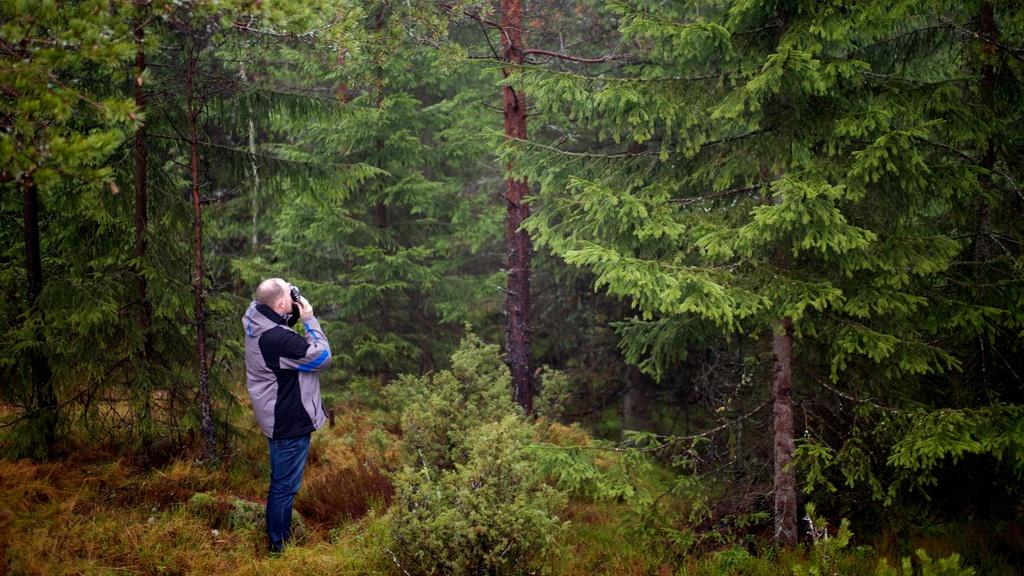What type of vegetation is at the bottom of the image? There is grass at the bottom of the image. What can be seen in the foreground of the image? There is a person wearing a jacket in the foreground of the image. What type of natural scenery is visible in the background of the image? There are trees in the background of the image. What type of stove is visible in the image? There is no stove present in the image. How many men are depicted in the image? The image does not show any men; it only features a person wearing a jacket. 